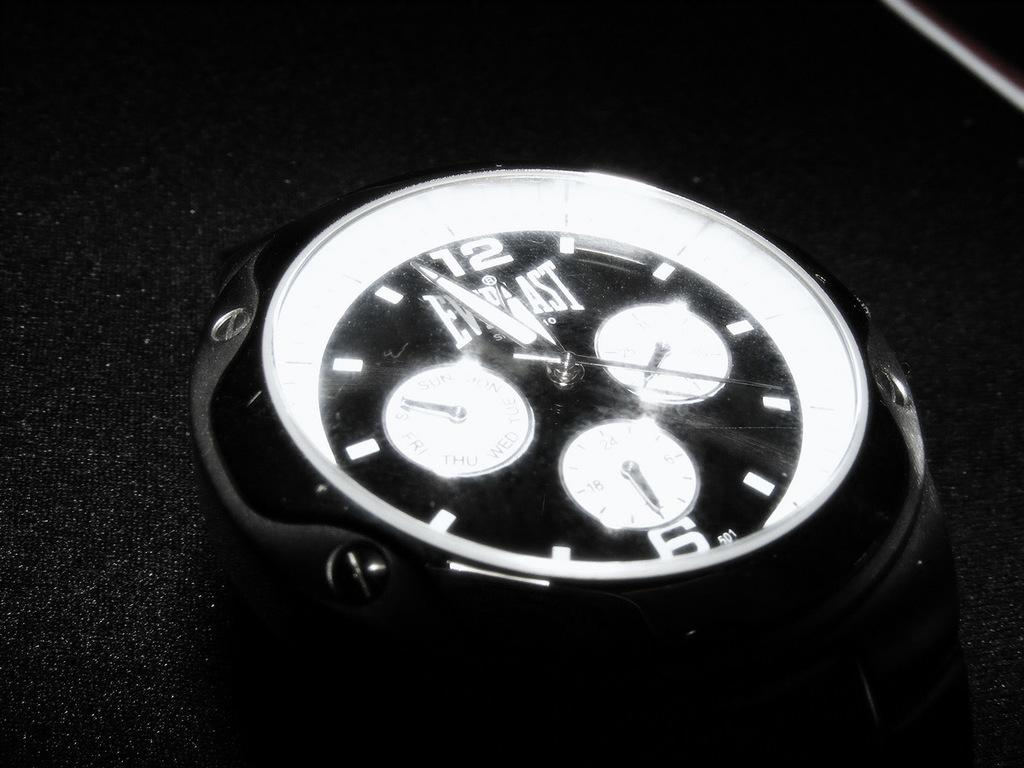<image>
Give a short and clear explanation of the subsequent image. The watch in the picture is from the company Everlast 